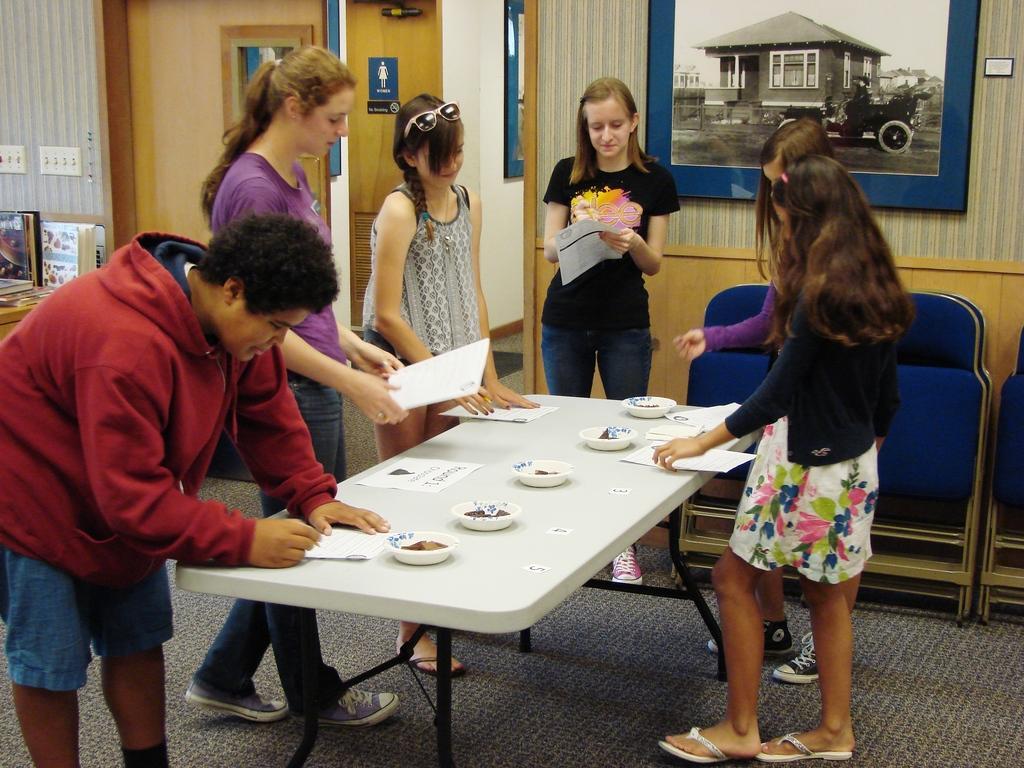How would you summarize this image in a sentence or two? This picture shows a group of people standing holding papers in their hands and we see a man writing on the paper on the table and we see few cups and we see a photo frame on the wall 